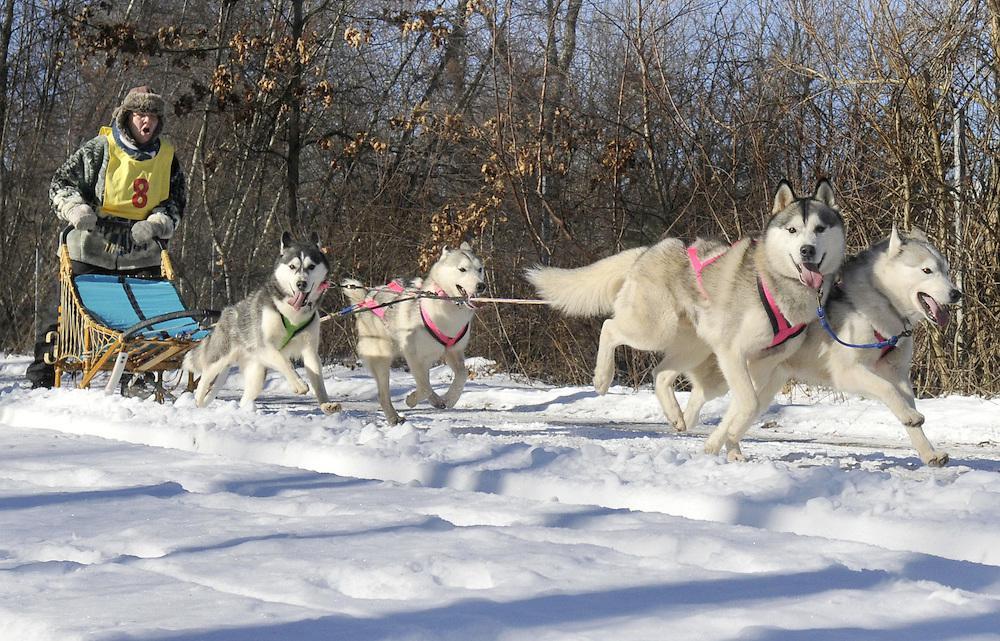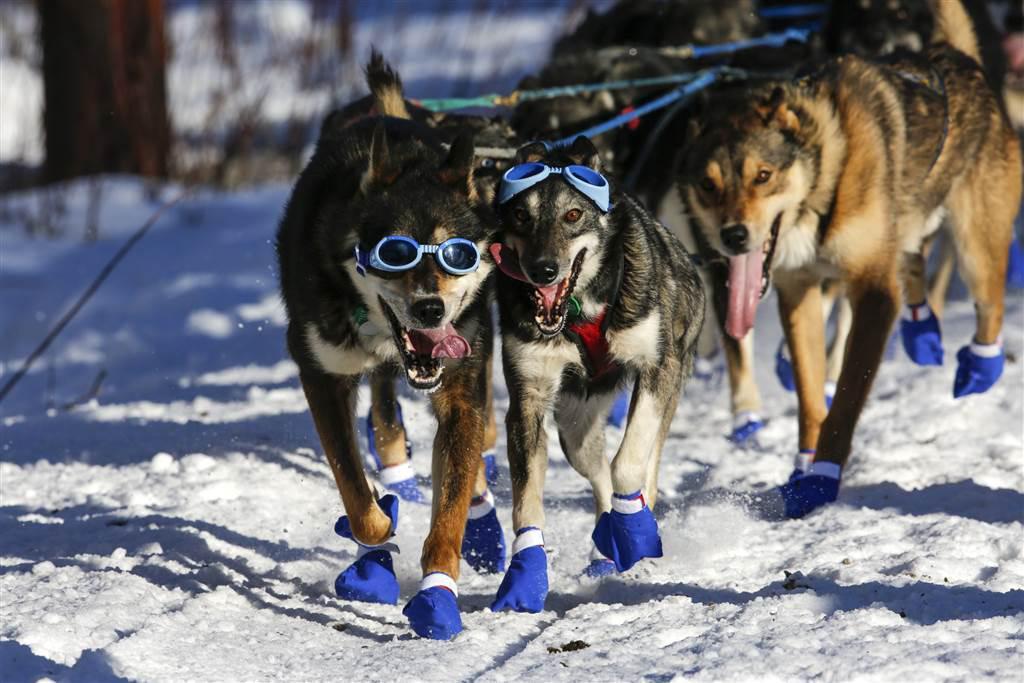The first image is the image on the left, the second image is the image on the right. For the images shown, is this caption "Some dogs are wearing gloves that aren't black." true? Answer yes or no. Yes. The first image is the image on the left, the second image is the image on the right. Assess this claim about the two images: "A team of dogs wear the same non-black color of booties.". Correct or not? Answer yes or no. Yes. 